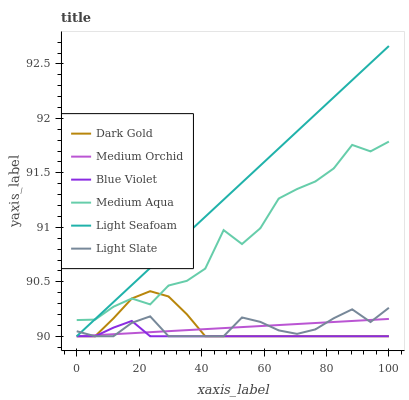Does Blue Violet have the minimum area under the curve?
Answer yes or no. Yes. Does Light Seafoam have the maximum area under the curve?
Answer yes or no. Yes. Does Light Slate have the minimum area under the curve?
Answer yes or no. No. Does Light Slate have the maximum area under the curve?
Answer yes or no. No. Is Medium Orchid the smoothest?
Answer yes or no. Yes. Is Medium Aqua the roughest?
Answer yes or no. Yes. Is Light Slate the smoothest?
Answer yes or no. No. Is Light Slate the roughest?
Answer yes or no. No. Does Dark Gold have the lowest value?
Answer yes or no. Yes. Does Medium Aqua have the lowest value?
Answer yes or no. No. Does Light Seafoam have the highest value?
Answer yes or no. Yes. Does Light Slate have the highest value?
Answer yes or no. No. Is Light Slate less than Medium Aqua?
Answer yes or no. Yes. Is Medium Aqua greater than Light Slate?
Answer yes or no. Yes. Does Light Seafoam intersect Dark Gold?
Answer yes or no. Yes. Is Light Seafoam less than Dark Gold?
Answer yes or no. No. Is Light Seafoam greater than Dark Gold?
Answer yes or no. No. Does Light Slate intersect Medium Aqua?
Answer yes or no. No. 